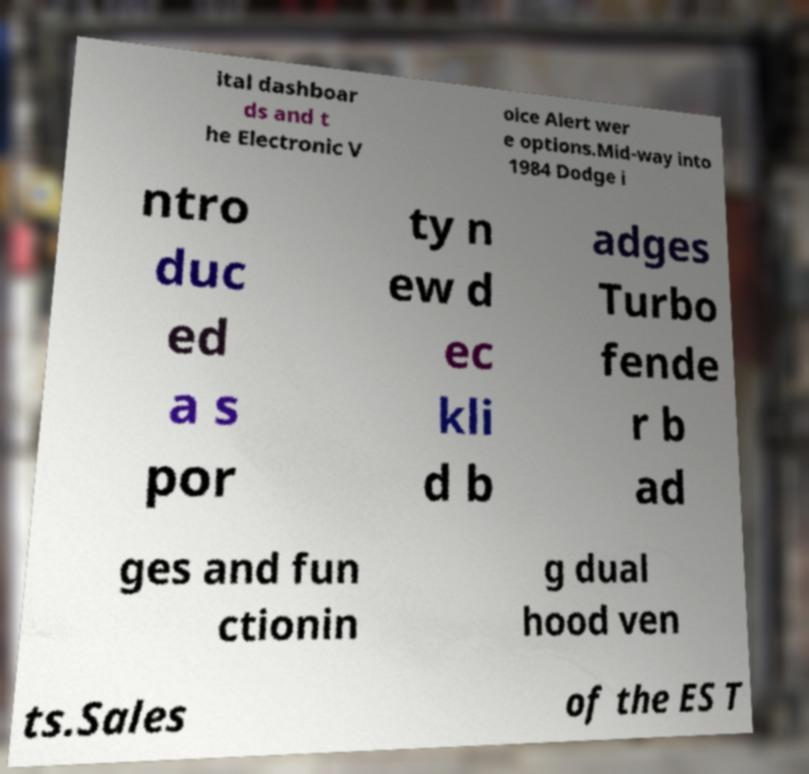Can you read and provide the text displayed in the image?This photo seems to have some interesting text. Can you extract and type it out for me? ital dashboar ds and t he Electronic V oice Alert wer e options.Mid-way into 1984 Dodge i ntro duc ed a s por ty n ew d ec kli d b adges Turbo fende r b ad ges and fun ctionin g dual hood ven ts.Sales of the ES T 